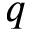<formula> <loc_0><loc_0><loc_500><loc_500>q</formula> 